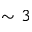<formula> <loc_0><loc_0><loc_500><loc_500>\sim 3</formula> 